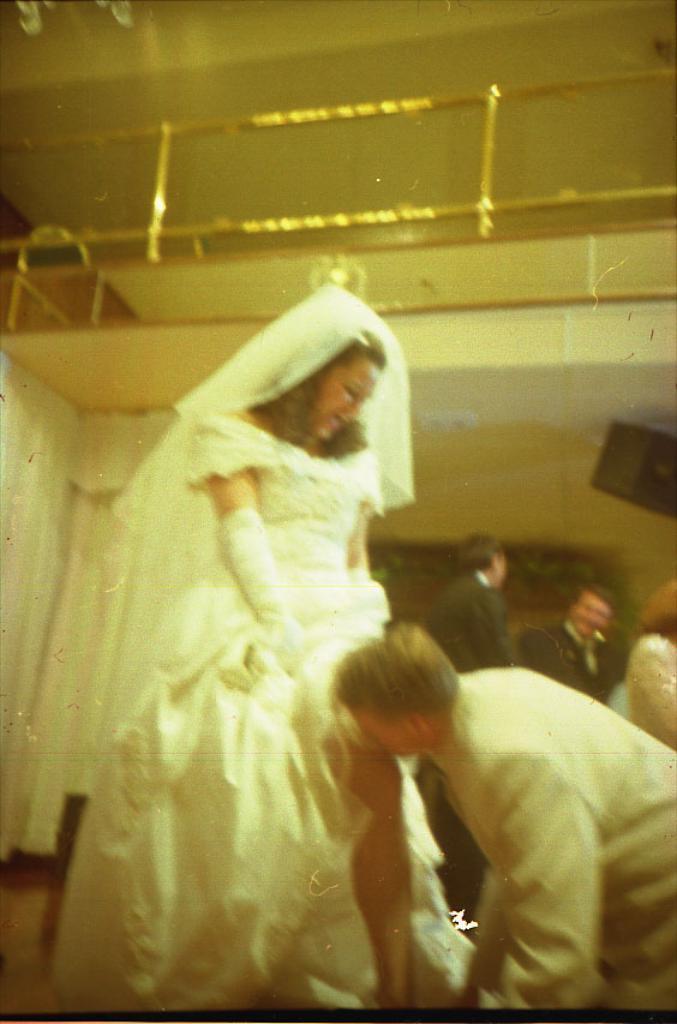Can you describe this image briefly? In this image I can see the group of people with white and black color dresses. In the background I can see curtains and the railing. 